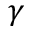<formula> <loc_0><loc_0><loc_500><loc_500>\gamma</formula> 